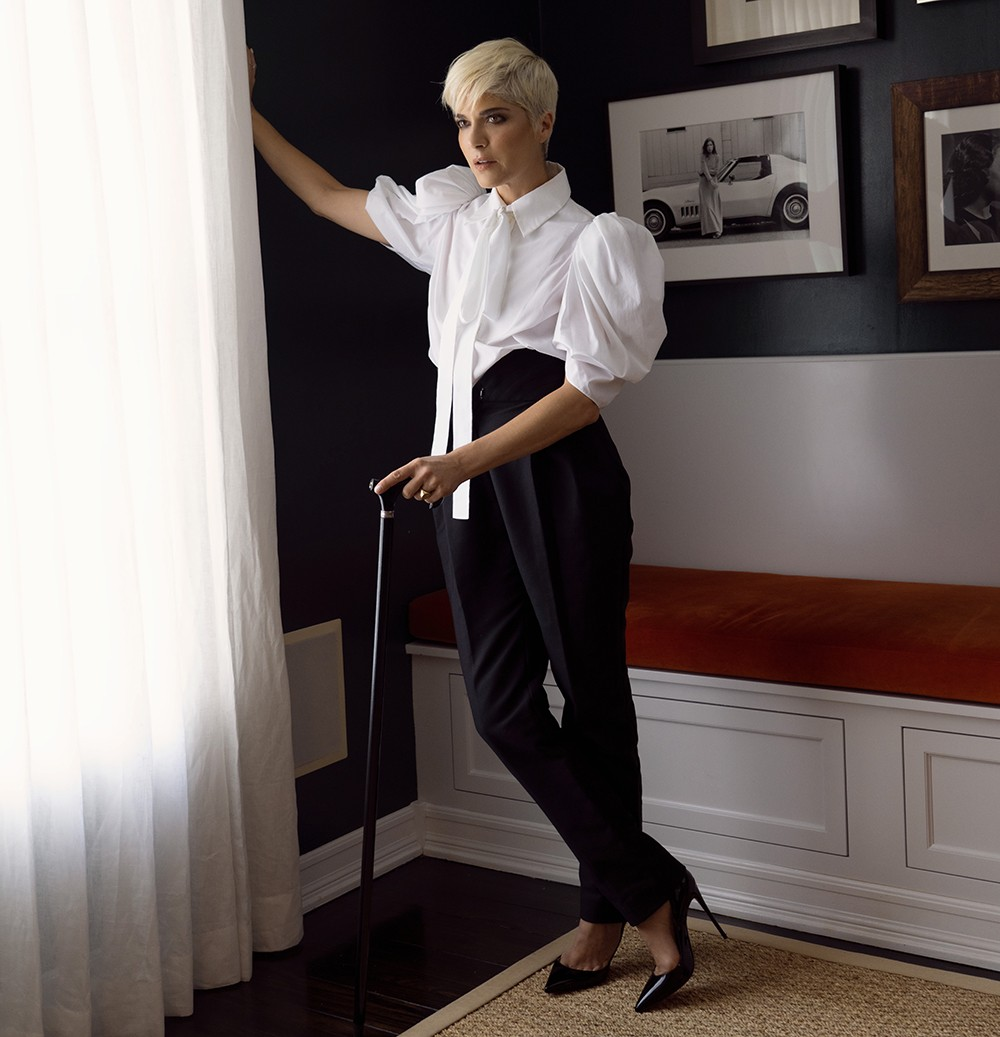What emotions do you think the person in the image is feeling? The person in the image appears to be in deep contemplation. Her serious expression and angled gaze suggest a moment of profound thought or reflection. There is a sense of resilience and perhaps a touch of solemnity, amplified by her poised stance and the cane she holds. The ambiance of the room, with its stark contrasts and inviting cushion, adds to the complexity of emotions conveyed—a blend of strength, determination, and introspection. 